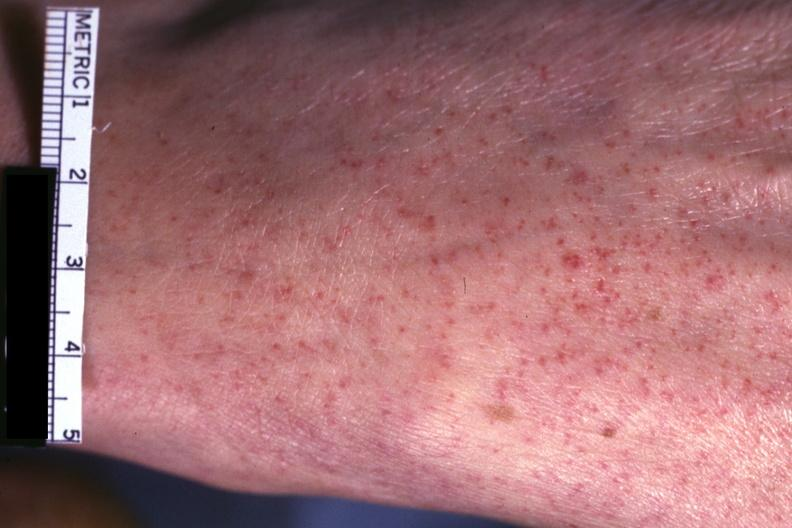does this image show good close-up of lesions?
Answer the question using a single word or phrase. Yes 